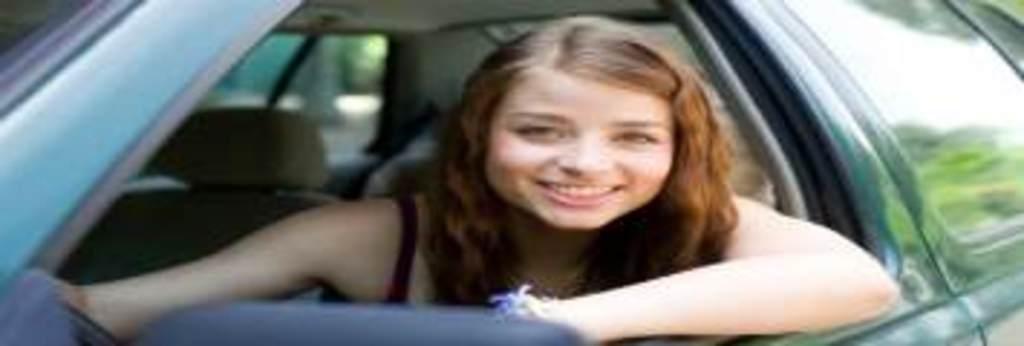Describe this image in one or two sentences. In this picture there is a woman sitting on a car, the car is in blue color. Background of the women there is a seat in the car. 